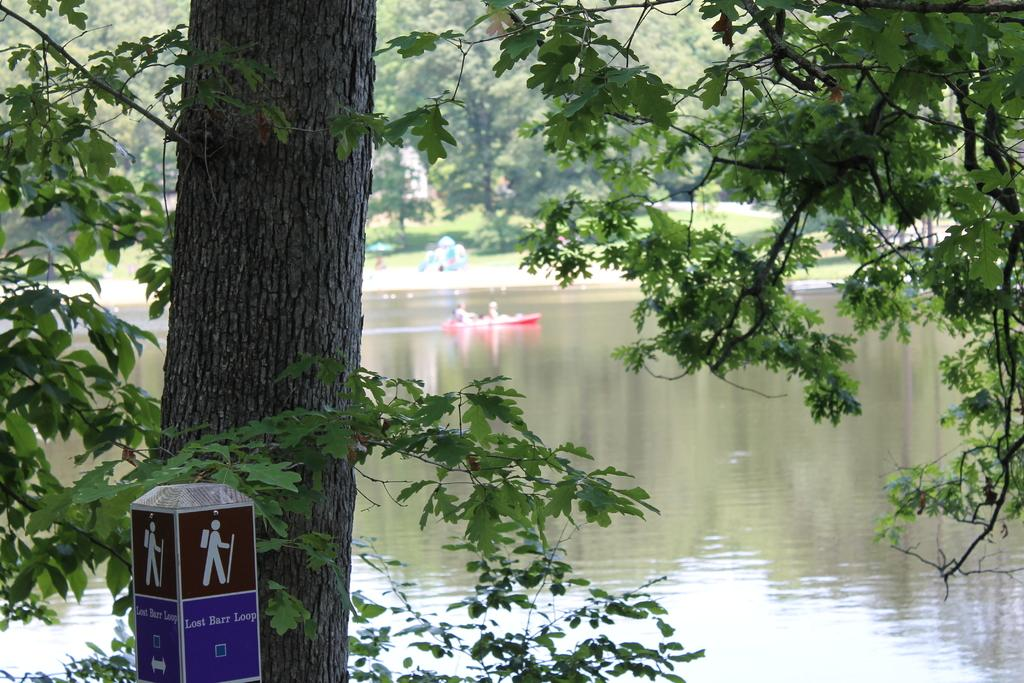What type of structures are present in the image? There are sign boards and a stone pillar in the image. What type of vegetation is visible in the image? There are trees in the image. What are the people in the image doing? There are two people in a boat in the image. Where is the boat located in the image? The boat is in the water in the image. What is present on the grass in the image? There are objects on the grass in the image. Can you see a sofa in the image? No, there is no sofa present in the image. How do the people in the boat say good-bye to each other? There is no indication of the people saying good-bye in the image. 